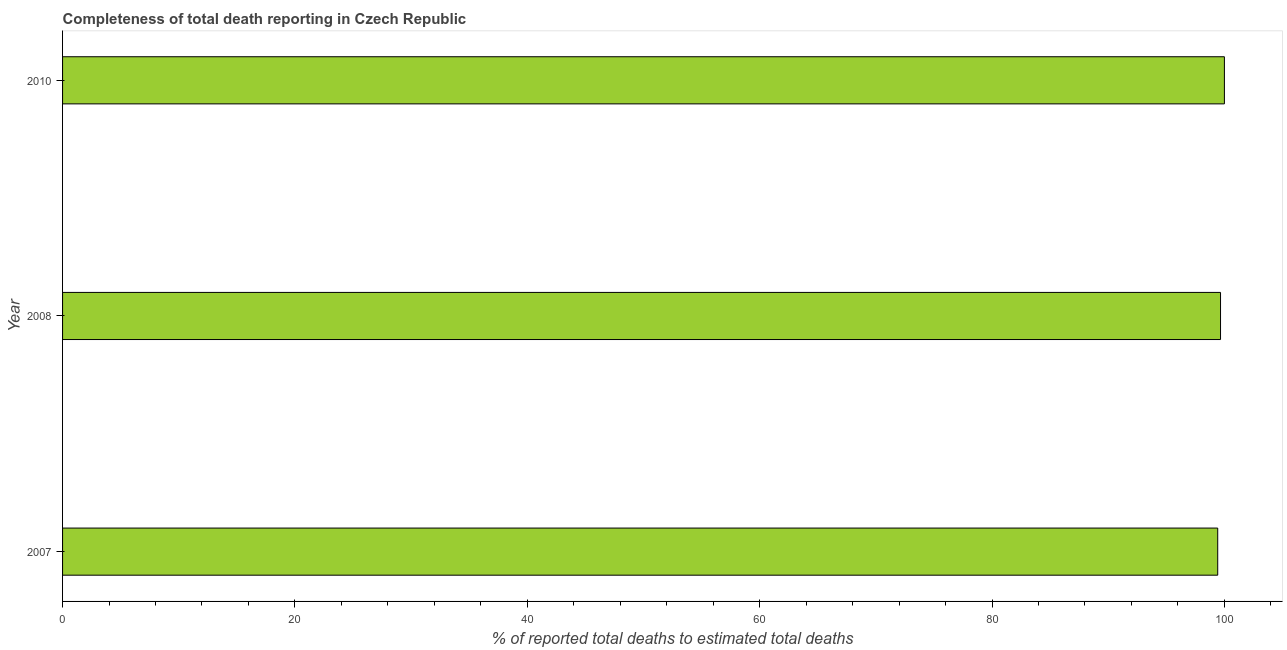Does the graph contain grids?
Offer a very short reply. No. What is the title of the graph?
Keep it short and to the point. Completeness of total death reporting in Czech Republic. What is the label or title of the X-axis?
Offer a terse response. % of reported total deaths to estimated total deaths. What is the completeness of total death reports in 2010?
Make the answer very short. 100. Across all years, what is the maximum completeness of total death reports?
Make the answer very short. 100. Across all years, what is the minimum completeness of total death reports?
Your response must be concise. 99.43. What is the sum of the completeness of total death reports?
Your answer should be very brief. 299.09. What is the difference between the completeness of total death reports in 2007 and 2008?
Make the answer very short. -0.24. What is the average completeness of total death reports per year?
Offer a very short reply. 99.7. What is the median completeness of total death reports?
Offer a very short reply. 99.67. Is the completeness of total death reports in 2007 less than that in 2008?
Give a very brief answer. Yes. What is the difference between the highest and the second highest completeness of total death reports?
Your answer should be very brief. 0.33. What is the difference between the highest and the lowest completeness of total death reports?
Provide a succinct answer. 0.57. How many bars are there?
Ensure brevity in your answer.  3. Are all the bars in the graph horizontal?
Offer a terse response. Yes. How many years are there in the graph?
Keep it short and to the point. 3. What is the % of reported total deaths to estimated total deaths in 2007?
Make the answer very short. 99.43. What is the % of reported total deaths to estimated total deaths of 2008?
Provide a succinct answer. 99.67. What is the % of reported total deaths to estimated total deaths of 2010?
Your response must be concise. 100. What is the difference between the % of reported total deaths to estimated total deaths in 2007 and 2008?
Offer a terse response. -0.24. What is the difference between the % of reported total deaths to estimated total deaths in 2007 and 2010?
Provide a succinct answer. -0.57. What is the difference between the % of reported total deaths to estimated total deaths in 2008 and 2010?
Ensure brevity in your answer.  -0.33. What is the ratio of the % of reported total deaths to estimated total deaths in 2007 to that in 2008?
Offer a very short reply. 1. What is the ratio of the % of reported total deaths to estimated total deaths in 2008 to that in 2010?
Provide a succinct answer. 1. 